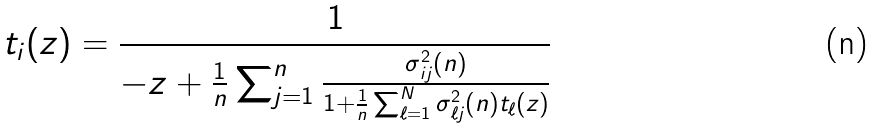Convert formula to latex. <formula><loc_0><loc_0><loc_500><loc_500>t _ { i } ( z ) = \frac { 1 } { - z + \frac { 1 } { n } \sum _ { j = 1 } ^ { n } \frac { \sigma ^ { 2 } _ { i j } ( n ) } { 1 + \frac { 1 } { n } \sum _ { \ell = 1 } ^ { N } \sigma ^ { 2 } _ { \ell j } ( n ) t _ { \ell } ( z ) } }</formula> 